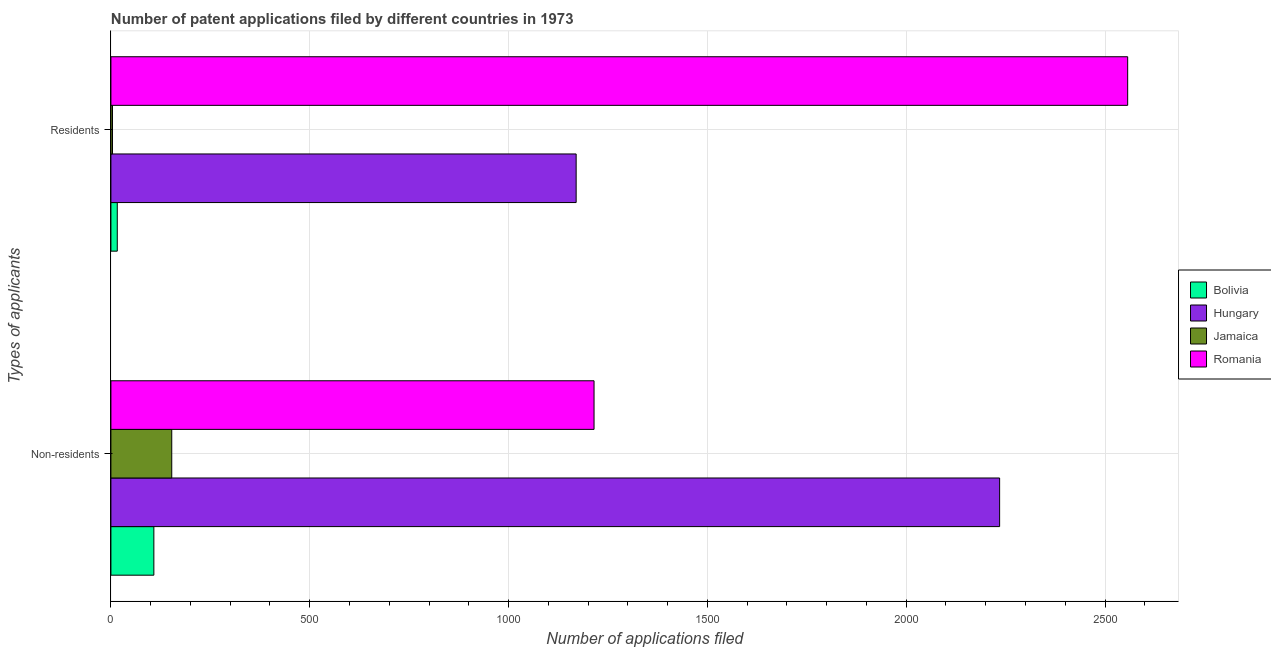How many groups of bars are there?
Your answer should be very brief. 2. Are the number of bars per tick equal to the number of legend labels?
Make the answer very short. Yes. Are the number of bars on each tick of the Y-axis equal?
Offer a very short reply. Yes. How many bars are there on the 1st tick from the top?
Your answer should be compact. 4. How many bars are there on the 1st tick from the bottom?
Make the answer very short. 4. What is the label of the 1st group of bars from the top?
Make the answer very short. Residents. What is the number of patent applications by non residents in Romania?
Make the answer very short. 1215. Across all countries, what is the maximum number of patent applications by non residents?
Make the answer very short. 2235. Across all countries, what is the minimum number of patent applications by non residents?
Offer a terse response. 108. In which country was the number of patent applications by residents maximum?
Your answer should be compact. Romania. In which country was the number of patent applications by residents minimum?
Provide a succinct answer. Jamaica. What is the total number of patent applications by residents in the graph?
Give a very brief answer. 3747. What is the difference between the number of patent applications by non residents in Jamaica and that in Hungary?
Your response must be concise. -2082. What is the difference between the number of patent applications by residents in Bolivia and the number of patent applications by non residents in Hungary?
Provide a short and direct response. -2219. What is the average number of patent applications by non residents per country?
Offer a very short reply. 927.75. What is the difference between the number of patent applications by residents and number of patent applications by non residents in Jamaica?
Ensure brevity in your answer.  -149. In how many countries, is the number of patent applications by residents greater than 2400 ?
Offer a very short reply. 1. What is the ratio of the number of patent applications by residents in Hungary to that in Jamaica?
Ensure brevity in your answer.  292.5. Is the number of patent applications by non residents in Hungary less than that in Romania?
Give a very brief answer. No. What does the 4th bar from the bottom in Non-residents represents?
Provide a succinct answer. Romania. Are all the bars in the graph horizontal?
Give a very brief answer. Yes. Are the values on the major ticks of X-axis written in scientific E-notation?
Provide a succinct answer. No. How many legend labels are there?
Your answer should be compact. 4. What is the title of the graph?
Your response must be concise. Number of patent applications filed by different countries in 1973. What is the label or title of the X-axis?
Keep it short and to the point. Number of applications filed. What is the label or title of the Y-axis?
Provide a succinct answer. Types of applicants. What is the Number of applications filed of Bolivia in Non-residents?
Ensure brevity in your answer.  108. What is the Number of applications filed in Hungary in Non-residents?
Make the answer very short. 2235. What is the Number of applications filed of Jamaica in Non-residents?
Keep it short and to the point. 153. What is the Number of applications filed in Romania in Non-residents?
Ensure brevity in your answer.  1215. What is the Number of applications filed in Hungary in Residents?
Your response must be concise. 1170. What is the Number of applications filed in Romania in Residents?
Keep it short and to the point. 2557. Across all Types of applicants, what is the maximum Number of applications filed of Bolivia?
Offer a terse response. 108. Across all Types of applicants, what is the maximum Number of applications filed in Hungary?
Give a very brief answer. 2235. Across all Types of applicants, what is the maximum Number of applications filed in Jamaica?
Your response must be concise. 153. Across all Types of applicants, what is the maximum Number of applications filed of Romania?
Your response must be concise. 2557. Across all Types of applicants, what is the minimum Number of applications filed of Hungary?
Your answer should be compact. 1170. Across all Types of applicants, what is the minimum Number of applications filed of Romania?
Make the answer very short. 1215. What is the total Number of applications filed of Bolivia in the graph?
Make the answer very short. 124. What is the total Number of applications filed of Hungary in the graph?
Keep it short and to the point. 3405. What is the total Number of applications filed of Jamaica in the graph?
Give a very brief answer. 157. What is the total Number of applications filed of Romania in the graph?
Provide a succinct answer. 3772. What is the difference between the Number of applications filed of Bolivia in Non-residents and that in Residents?
Your answer should be compact. 92. What is the difference between the Number of applications filed in Hungary in Non-residents and that in Residents?
Your answer should be very brief. 1065. What is the difference between the Number of applications filed in Jamaica in Non-residents and that in Residents?
Your answer should be very brief. 149. What is the difference between the Number of applications filed in Romania in Non-residents and that in Residents?
Provide a short and direct response. -1342. What is the difference between the Number of applications filed of Bolivia in Non-residents and the Number of applications filed of Hungary in Residents?
Ensure brevity in your answer.  -1062. What is the difference between the Number of applications filed in Bolivia in Non-residents and the Number of applications filed in Jamaica in Residents?
Your answer should be compact. 104. What is the difference between the Number of applications filed in Bolivia in Non-residents and the Number of applications filed in Romania in Residents?
Provide a succinct answer. -2449. What is the difference between the Number of applications filed of Hungary in Non-residents and the Number of applications filed of Jamaica in Residents?
Ensure brevity in your answer.  2231. What is the difference between the Number of applications filed of Hungary in Non-residents and the Number of applications filed of Romania in Residents?
Provide a succinct answer. -322. What is the difference between the Number of applications filed of Jamaica in Non-residents and the Number of applications filed of Romania in Residents?
Give a very brief answer. -2404. What is the average Number of applications filed in Hungary per Types of applicants?
Make the answer very short. 1702.5. What is the average Number of applications filed in Jamaica per Types of applicants?
Provide a short and direct response. 78.5. What is the average Number of applications filed in Romania per Types of applicants?
Your answer should be very brief. 1886. What is the difference between the Number of applications filed of Bolivia and Number of applications filed of Hungary in Non-residents?
Offer a terse response. -2127. What is the difference between the Number of applications filed of Bolivia and Number of applications filed of Jamaica in Non-residents?
Ensure brevity in your answer.  -45. What is the difference between the Number of applications filed of Bolivia and Number of applications filed of Romania in Non-residents?
Give a very brief answer. -1107. What is the difference between the Number of applications filed in Hungary and Number of applications filed in Jamaica in Non-residents?
Keep it short and to the point. 2082. What is the difference between the Number of applications filed in Hungary and Number of applications filed in Romania in Non-residents?
Provide a succinct answer. 1020. What is the difference between the Number of applications filed in Jamaica and Number of applications filed in Romania in Non-residents?
Your response must be concise. -1062. What is the difference between the Number of applications filed of Bolivia and Number of applications filed of Hungary in Residents?
Provide a short and direct response. -1154. What is the difference between the Number of applications filed of Bolivia and Number of applications filed of Jamaica in Residents?
Your response must be concise. 12. What is the difference between the Number of applications filed of Bolivia and Number of applications filed of Romania in Residents?
Give a very brief answer. -2541. What is the difference between the Number of applications filed in Hungary and Number of applications filed in Jamaica in Residents?
Offer a very short reply. 1166. What is the difference between the Number of applications filed of Hungary and Number of applications filed of Romania in Residents?
Ensure brevity in your answer.  -1387. What is the difference between the Number of applications filed in Jamaica and Number of applications filed in Romania in Residents?
Make the answer very short. -2553. What is the ratio of the Number of applications filed in Bolivia in Non-residents to that in Residents?
Offer a terse response. 6.75. What is the ratio of the Number of applications filed in Hungary in Non-residents to that in Residents?
Your answer should be compact. 1.91. What is the ratio of the Number of applications filed of Jamaica in Non-residents to that in Residents?
Ensure brevity in your answer.  38.25. What is the ratio of the Number of applications filed in Romania in Non-residents to that in Residents?
Ensure brevity in your answer.  0.48. What is the difference between the highest and the second highest Number of applications filed of Bolivia?
Make the answer very short. 92. What is the difference between the highest and the second highest Number of applications filed of Hungary?
Your answer should be very brief. 1065. What is the difference between the highest and the second highest Number of applications filed of Jamaica?
Your answer should be compact. 149. What is the difference between the highest and the second highest Number of applications filed in Romania?
Offer a very short reply. 1342. What is the difference between the highest and the lowest Number of applications filed of Bolivia?
Your answer should be very brief. 92. What is the difference between the highest and the lowest Number of applications filed of Hungary?
Your answer should be compact. 1065. What is the difference between the highest and the lowest Number of applications filed of Jamaica?
Provide a succinct answer. 149. What is the difference between the highest and the lowest Number of applications filed of Romania?
Provide a short and direct response. 1342. 